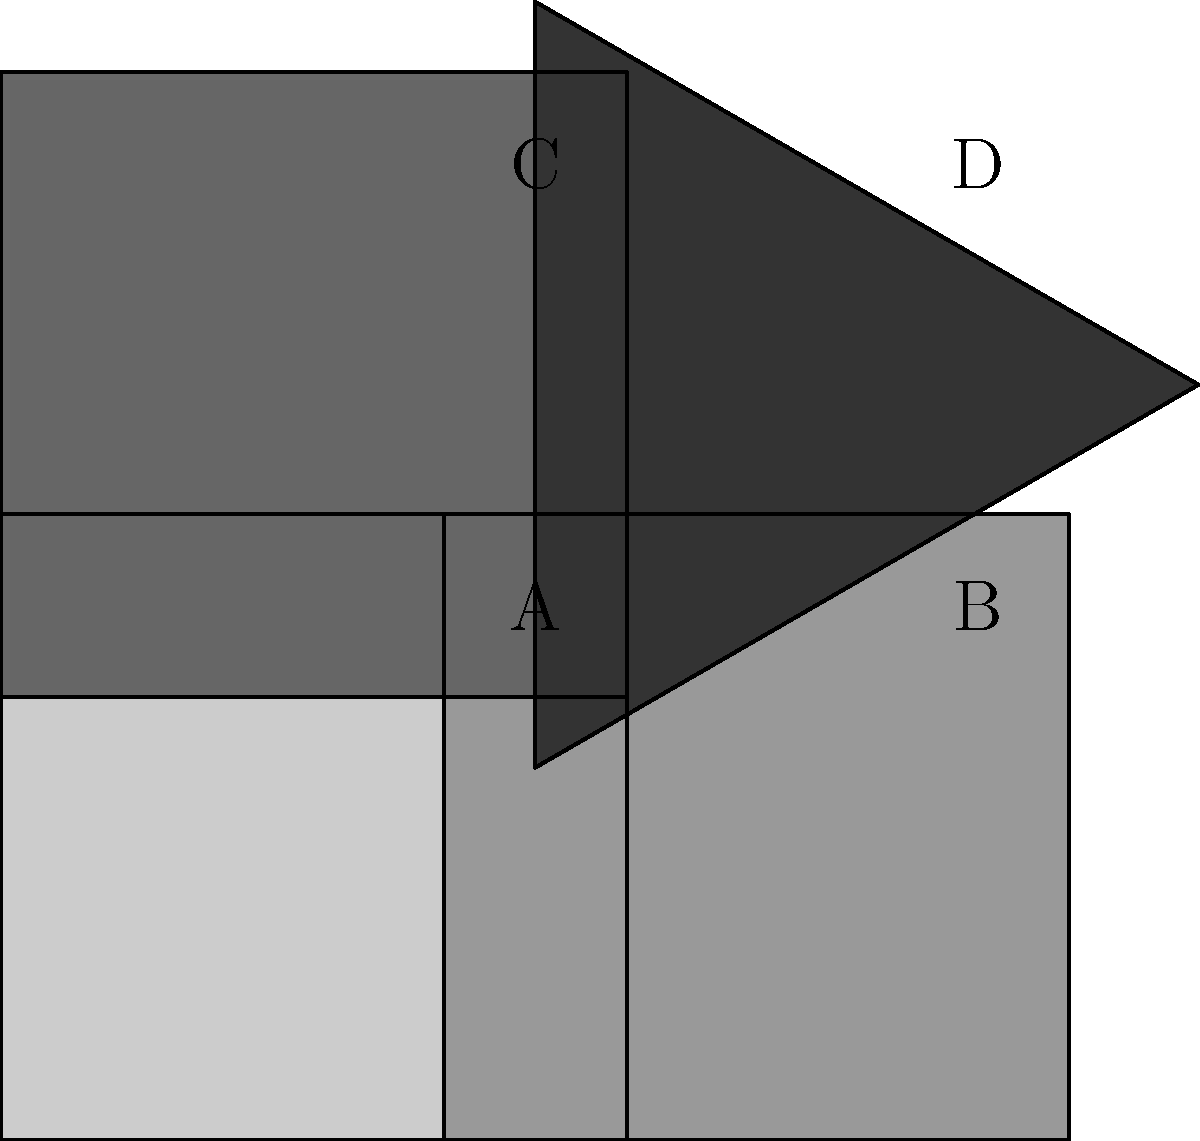Check out this cool shape puzzle! Which piece needs to be rotated 90° clockwise to complete the square? Let's break this down step-by-step:

1. We have a 2x2 grid with four pieces: A, B, C, and D.
2. Pieces A, B, and C are squares, while piece D is a triangle.
3. To complete the square, we need all four pieces to be squares.
4. Looking at each piece:
   - Piece A is already a square and correctly positioned.
   - Piece B is a square but rotated 90° counterclockwise.
   - Piece C is a square but rotated 180°.
   - Piece D is a triangle and cannot become a square by rotation.
5. To make the puzzle a complete square, we need to rotate piece B 90° clockwise.
   This will align its sides with the adjacent pieces.

Therefore, piece B is the one that needs to be rotated 90° clockwise to complete the square.
Answer: B 